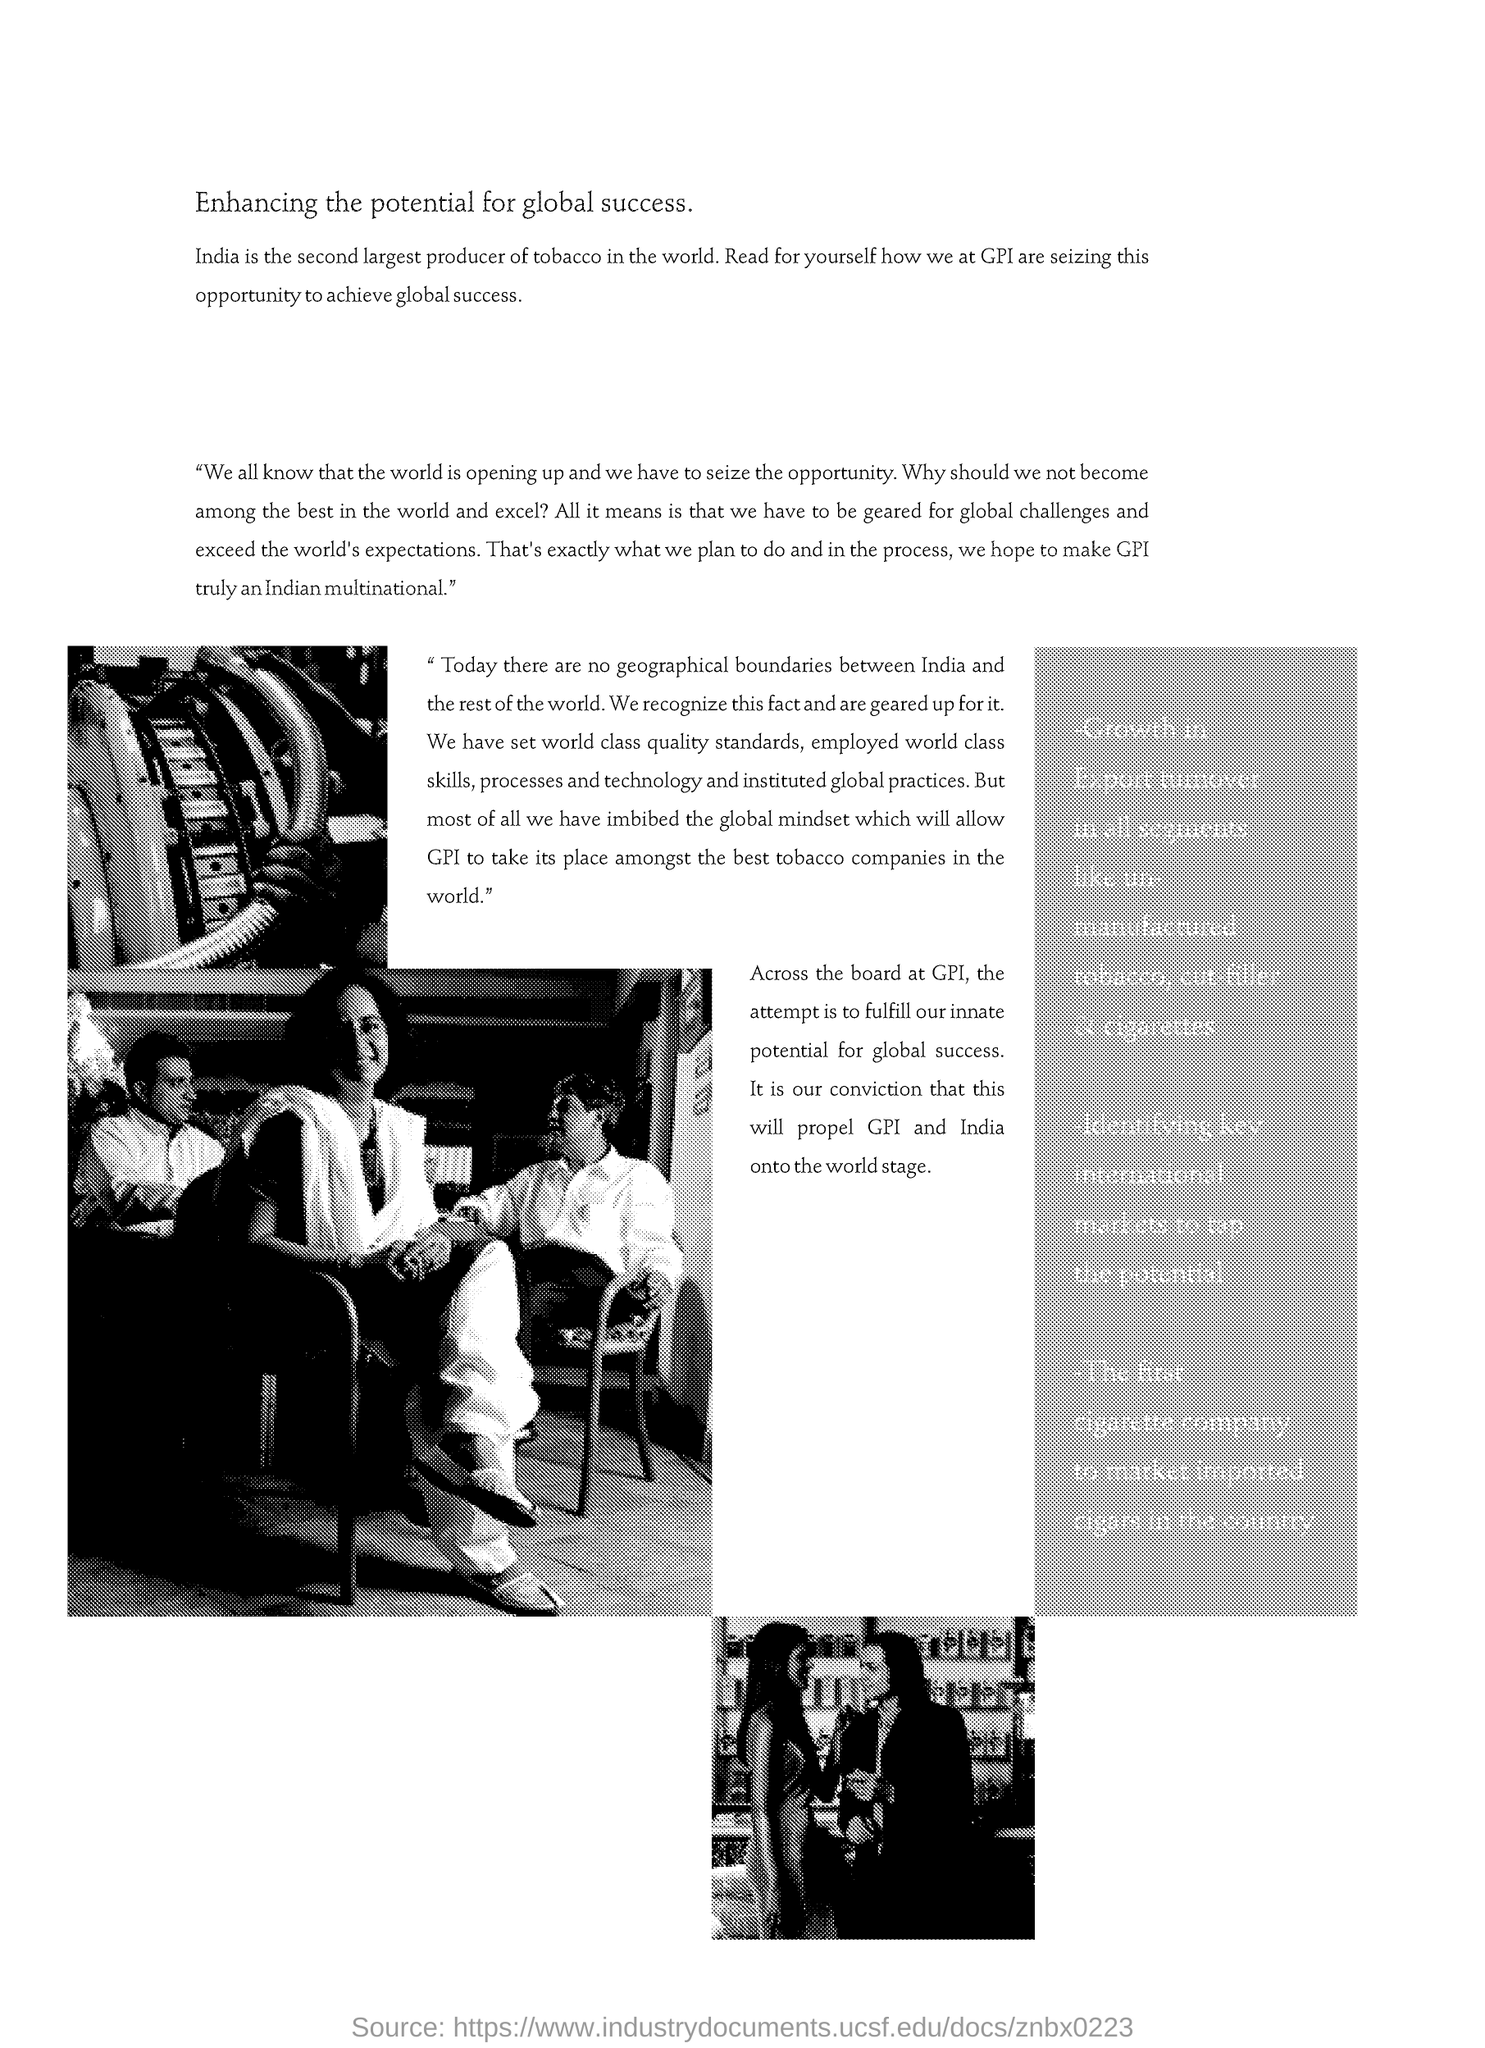List a handful of essential elements in this visual. India is the second largest producer of tobacco in the world. 